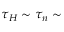<formula> <loc_0><loc_0><loc_500><loc_500>\tau _ { H } \sim \tau _ { n } \sim</formula> 